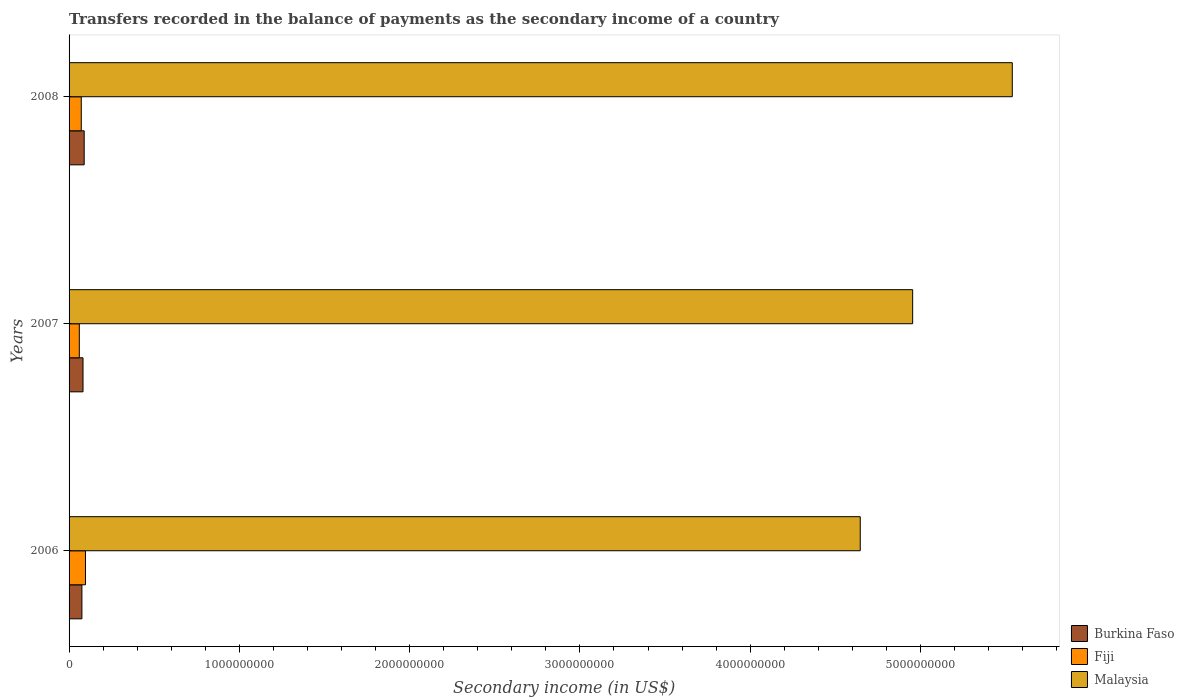Are the number of bars per tick equal to the number of legend labels?
Your response must be concise. Yes. How many bars are there on the 3rd tick from the top?
Provide a short and direct response. 3. How many bars are there on the 2nd tick from the bottom?
Your response must be concise. 3. What is the label of the 1st group of bars from the top?
Your response must be concise. 2008. What is the secondary income of in Burkina Faso in 2008?
Provide a succinct answer. 8.88e+07. Across all years, what is the maximum secondary income of in Burkina Faso?
Keep it short and to the point. 8.88e+07. Across all years, what is the minimum secondary income of in Fiji?
Offer a terse response. 6.01e+07. In which year was the secondary income of in Malaysia minimum?
Give a very brief answer. 2006. What is the total secondary income of in Malaysia in the graph?
Your answer should be compact. 1.51e+1. What is the difference between the secondary income of in Fiji in 2007 and that in 2008?
Offer a very short reply. -1.15e+07. What is the difference between the secondary income of in Malaysia in 2006 and the secondary income of in Fiji in 2008?
Give a very brief answer. 4.57e+09. What is the average secondary income of in Burkina Faso per year?
Make the answer very short. 8.20e+07. In the year 2006, what is the difference between the secondary income of in Burkina Faso and secondary income of in Malaysia?
Make the answer very short. -4.57e+09. What is the ratio of the secondary income of in Burkina Faso in 2007 to that in 2008?
Provide a short and direct response. 0.92. Is the secondary income of in Burkina Faso in 2006 less than that in 2007?
Keep it short and to the point. Yes. Is the difference between the secondary income of in Burkina Faso in 2006 and 2008 greater than the difference between the secondary income of in Malaysia in 2006 and 2008?
Provide a succinct answer. Yes. What is the difference between the highest and the second highest secondary income of in Burkina Faso?
Your answer should be very brief. 6.88e+06. What is the difference between the highest and the lowest secondary income of in Burkina Faso?
Provide a succinct answer. 1.35e+07. What does the 1st bar from the top in 2008 represents?
Keep it short and to the point. Malaysia. What does the 2nd bar from the bottom in 2006 represents?
Your response must be concise. Fiji. Is it the case that in every year, the sum of the secondary income of in Malaysia and secondary income of in Fiji is greater than the secondary income of in Burkina Faso?
Provide a succinct answer. Yes. How many bars are there?
Your answer should be compact. 9. Are all the bars in the graph horizontal?
Keep it short and to the point. Yes. How many years are there in the graph?
Provide a short and direct response. 3. What is the difference between two consecutive major ticks on the X-axis?
Offer a terse response. 1.00e+09. Are the values on the major ticks of X-axis written in scientific E-notation?
Offer a terse response. No. Does the graph contain any zero values?
Your answer should be very brief. No. Does the graph contain grids?
Your response must be concise. No. Where does the legend appear in the graph?
Ensure brevity in your answer.  Bottom right. How many legend labels are there?
Give a very brief answer. 3. What is the title of the graph?
Your answer should be very brief. Transfers recorded in the balance of payments as the secondary income of a country. Does "Albania" appear as one of the legend labels in the graph?
Your answer should be very brief. No. What is the label or title of the X-axis?
Offer a very short reply. Secondary income (in US$). What is the label or title of the Y-axis?
Your answer should be compact. Years. What is the Secondary income (in US$) in Burkina Faso in 2006?
Offer a very short reply. 7.53e+07. What is the Secondary income (in US$) in Fiji in 2006?
Offer a terse response. 9.63e+07. What is the Secondary income (in US$) of Malaysia in 2006?
Make the answer very short. 4.65e+09. What is the Secondary income (in US$) of Burkina Faso in 2007?
Offer a very short reply. 8.19e+07. What is the Secondary income (in US$) in Fiji in 2007?
Keep it short and to the point. 6.01e+07. What is the Secondary income (in US$) of Malaysia in 2007?
Offer a very short reply. 4.95e+09. What is the Secondary income (in US$) in Burkina Faso in 2008?
Give a very brief answer. 8.88e+07. What is the Secondary income (in US$) of Fiji in 2008?
Ensure brevity in your answer.  7.16e+07. What is the Secondary income (in US$) of Malaysia in 2008?
Your response must be concise. 5.54e+09. Across all years, what is the maximum Secondary income (in US$) of Burkina Faso?
Offer a terse response. 8.88e+07. Across all years, what is the maximum Secondary income (in US$) in Fiji?
Provide a succinct answer. 9.63e+07. Across all years, what is the maximum Secondary income (in US$) of Malaysia?
Provide a short and direct response. 5.54e+09. Across all years, what is the minimum Secondary income (in US$) in Burkina Faso?
Offer a very short reply. 7.53e+07. Across all years, what is the minimum Secondary income (in US$) of Fiji?
Keep it short and to the point. 6.01e+07. Across all years, what is the minimum Secondary income (in US$) in Malaysia?
Ensure brevity in your answer.  4.65e+09. What is the total Secondary income (in US$) of Burkina Faso in the graph?
Make the answer very short. 2.46e+08. What is the total Secondary income (in US$) of Fiji in the graph?
Give a very brief answer. 2.28e+08. What is the total Secondary income (in US$) of Malaysia in the graph?
Provide a succinct answer. 1.51e+1. What is the difference between the Secondary income (in US$) of Burkina Faso in 2006 and that in 2007?
Offer a terse response. -6.57e+06. What is the difference between the Secondary income (in US$) in Fiji in 2006 and that in 2007?
Ensure brevity in your answer.  3.62e+07. What is the difference between the Secondary income (in US$) in Malaysia in 2006 and that in 2007?
Provide a succinct answer. -3.08e+08. What is the difference between the Secondary income (in US$) of Burkina Faso in 2006 and that in 2008?
Provide a short and direct response. -1.35e+07. What is the difference between the Secondary income (in US$) in Fiji in 2006 and that in 2008?
Offer a very short reply. 2.47e+07. What is the difference between the Secondary income (in US$) in Malaysia in 2006 and that in 2008?
Your answer should be compact. -8.93e+08. What is the difference between the Secondary income (in US$) of Burkina Faso in 2007 and that in 2008?
Your answer should be compact. -6.88e+06. What is the difference between the Secondary income (in US$) of Fiji in 2007 and that in 2008?
Provide a succinct answer. -1.15e+07. What is the difference between the Secondary income (in US$) in Malaysia in 2007 and that in 2008?
Provide a succinct answer. -5.85e+08. What is the difference between the Secondary income (in US$) of Burkina Faso in 2006 and the Secondary income (in US$) of Fiji in 2007?
Provide a short and direct response. 1.52e+07. What is the difference between the Secondary income (in US$) in Burkina Faso in 2006 and the Secondary income (in US$) in Malaysia in 2007?
Your response must be concise. -4.88e+09. What is the difference between the Secondary income (in US$) in Fiji in 2006 and the Secondary income (in US$) in Malaysia in 2007?
Your answer should be compact. -4.86e+09. What is the difference between the Secondary income (in US$) of Burkina Faso in 2006 and the Secondary income (in US$) of Fiji in 2008?
Provide a short and direct response. 3.72e+06. What is the difference between the Secondary income (in US$) in Burkina Faso in 2006 and the Secondary income (in US$) in Malaysia in 2008?
Offer a terse response. -5.46e+09. What is the difference between the Secondary income (in US$) in Fiji in 2006 and the Secondary income (in US$) in Malaysia in 2008?
Provide a succinct answer. -5.44e+09. What is the difference between the Secondary income (in US$) in Burkina Faso in 2007 and the Secondary income (in US$) in Fiji in 2008?
Keep it short and to the point. 1.03e+07. What is the difference between the Secondary income (in US$) in Burkina Faso in 2007 and the Secondary income (in US$) in Malaysia in 2008?
Offer a terse response. -5.46e+09. What is the difference between the Secondary income (in US$) in Fiji in 2007 and the Secondary income (in US$) in Malaysia in 2008?
Provide a succinct answer. -5.48e+09. What is the average Secondary income (in US$) in Burkina Faso per year?
Provide a succinct answer. 8.20e+07. What is the average Secondary income (in US$) of Fiji per year?
Ensure brevity in your answer.  7.60e+07. What is the average Secondary income (in US$) in Malaysia per year?
Your answer should be compact. 5.05e+09. In the year 2006, what is the difference between the Secondary income (in US$) of Burkina Faso and Secondary income (in US$) of Fiji?
Your answer should be compact. -2.09e+07. In the year 2006, what is the difference between the Secondary income (in US$) in Burkina Faso and Secondary income (in US$) in Malaysia?
Offer a terse response. -4.57e+09. In the year 2006, what is the difference between the Secondary income (in US$) of Fiji and Secondary income (in US$) of Malaysia?
Provide a short and direct response. -4.55e+09. In the year 2007, what is the difference between the Secondary income (in US$) in Burkina Faso and Secondary income (in US$) in Fiji?
Offer a terse response. 2.18e+07. In the year 2007, what is the difference between the Secondary income (in US$) in Burkina Faso and Secondary income (in US$) in Malaysia?
Provide a succinct answer. -4.87e+09. In the year 2007, what is the difference between the Secondary income (in US$) in Fiji and Secondary income (in US$) in Malaysia?
Your response must be concise. -4.89e+09. In the year 2008, what is the difference between the Secondary income (in US$) of Burkina Faso and Secondary income (in US$) of Fiji?
Your answer should be compact. 1.72e+07. In the year 2008, what is the difference between the Secondary income (in US$) in Burkina Faso and Secondary income (in US$) in Malaysia?
Your response must be concise. -5.45e+09. In the year 2008, what is the difference between the Secondary income (in US$) in Fiji and Secondary income (in US$) in Malaysia?
Offer a very short reply. -5.47e+09. What is the ratio of the Secondary income (in US$) in Burkina Faso in 2006 to that in 2007?
Your answer should be very brief. 0.92. What is the ratio of the Secondary income (in US$) of Fiji in 2006 to that in 2007?
Make the answer very short. 1.6. What is the ratio of the Secondary income (in US$) in Malaysia in 2006 to that in 2007?
Give a very brief answer. 0.94. What is the ratio of the Secondary income (in US$) of Burkina Faso in 2006 to that in 2008?
Offer a terse response. 0.85. What is the ratio of the Secondary income (in US$) of Fiji in 2006 to that in 2008?
Provide a short and direct response. 1.34. What is the ratio of the Secondary income (in US$) in Malaysia in 2006 to that in 2008?
Offer a very short reply. 0.84. What is the ratio of the Secondary income (in US$) of Burkina Faso in 2007 to that in 2008?
Provide a succinct answer. 0.92. What is the ratio of the Secondary income (in US$) in Fiji in 2007 to that in 2008?
Your response must be concise. 0.84. What is the ratio of the Secondary income (in US$) of Malaysia in 2007 to that in 2008?
Provide a short and direct response. 0.89. What is the difference between the highest and the second highest Secondary income (in US$) in Burkina Faso?
Offer a very short reply. 6.88e+06. What is the difference between the highest and the second highest Secondary income (in US$) in Fiji?
Give a very brief answer. 2.47e+07. What is the difference between the highest and the second highest Secondary income (in US$) of Malaysia?
Give a very brief answer. 5.85e+08. What is the difference between the highest and the lowest Secondary income (in US$) of Burkina Faso?
Offer a terse response. 1.35e+07. What is the difference between the highest and the lowest Secondary income (in US$) in Fiji?
Provide a succinct answer. 3.62e+07. What is the difference between the highest and the lowest Secondary income (in US$) in Malaysia?
Provide a succinct answer. 8.93e+08. 